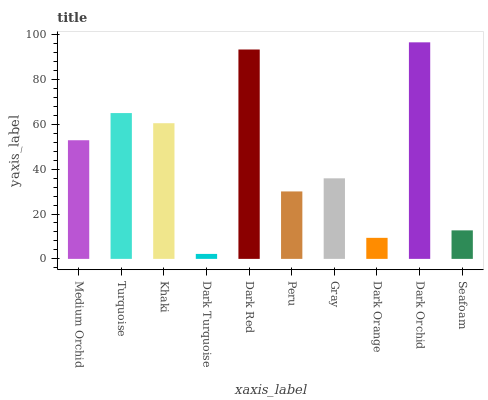Is Dark Turquoise the minimum?
Answer yes or no. Yes. Is Dark Orchid the maximum?
Answer yes or no. Yes. Is Turquoise the minimum?
Answer yes or no. No. Is Turquoise the maximum?
Answer yes or no. No. Is Turquoise greater than Medium Orchid?
Answer yes or no. Yes. Is Medium Orchid less than Turquoise?
Answer yes or no. Yes. Is Medium Orchid greater than Turquoise?
Answer yes or no. No. Is Turquoise less than Medium Orchid?
Answer yes or no. No. Is Medium Orchid the high median?
Answer yes or no. Yes. Is Gray the low median?
Answer yes or no. Yes. Is Khaki the high median?
Answer yes or no. No. Is Seafoam the low median?
Answer yes or no. No. 